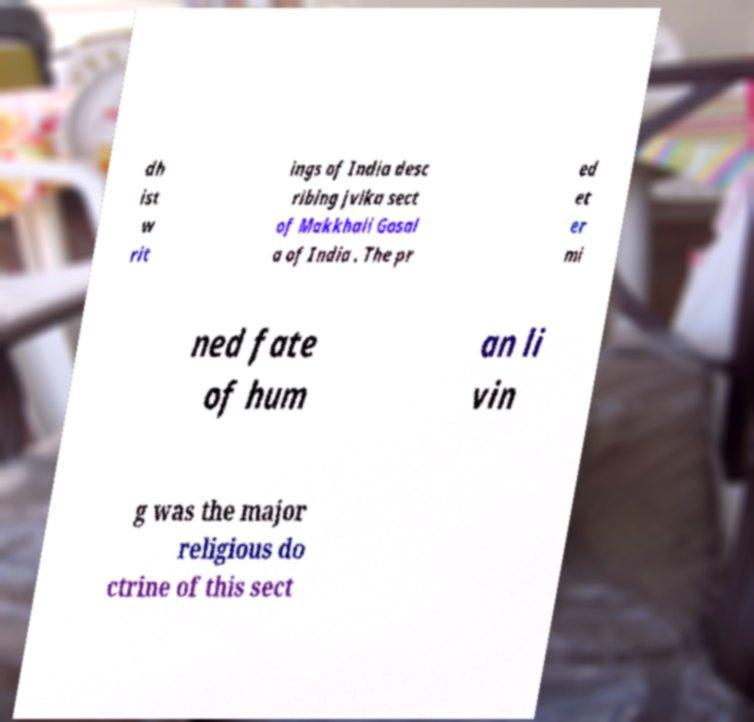Please read and relay the text visible in this image. What does it say? dh ist w rit ings of India desc ribing jvika sect of Makkhali Gosal a of India . The pr ed et er mi ned fate of hum an li vin g was the major religious do ctrine of this sect 